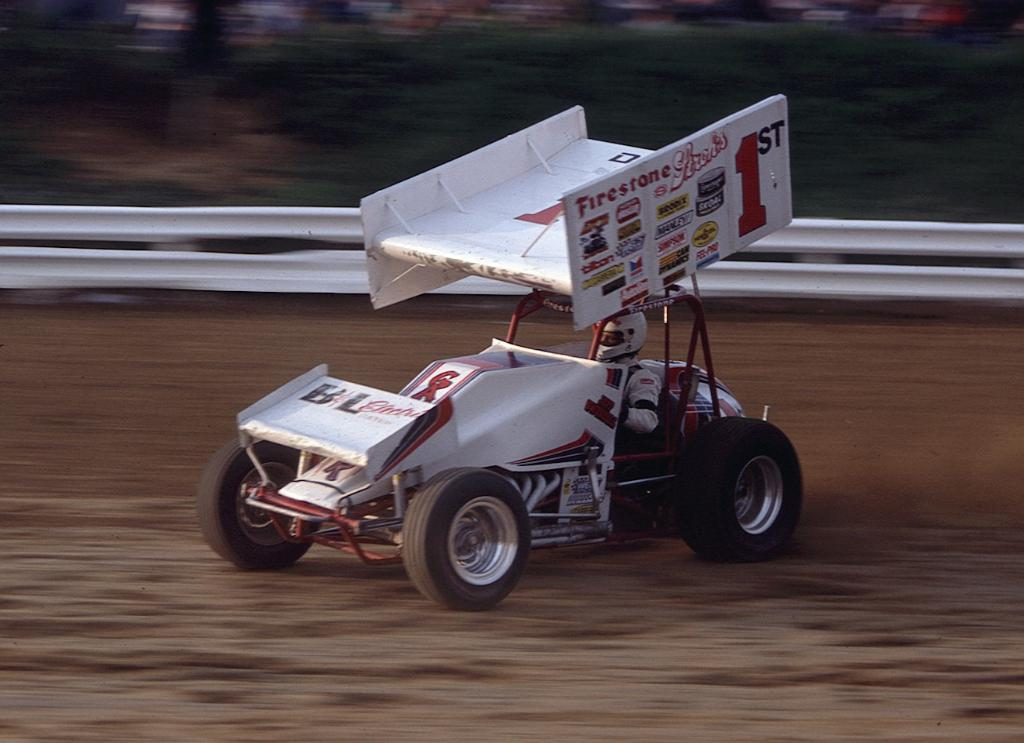<image>
Create a compact narrative representing the image presented. a white race car with the brand Tilton as a sponsor 